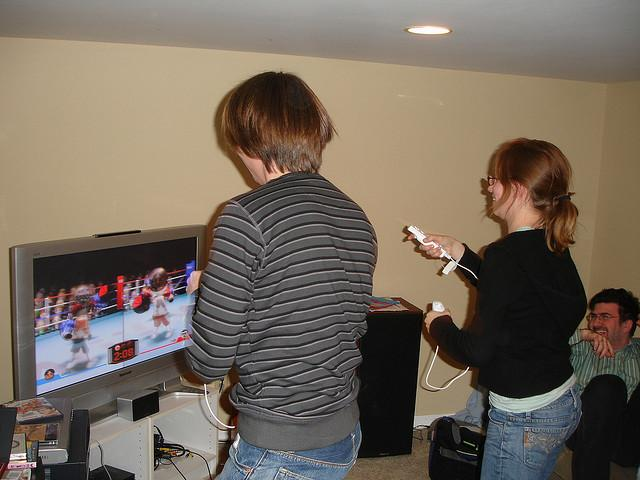What color shirt does the person opposing the wii woman in black?

Choices:
A) striped gray
B) green stripe
C) black
D) none striped gray 